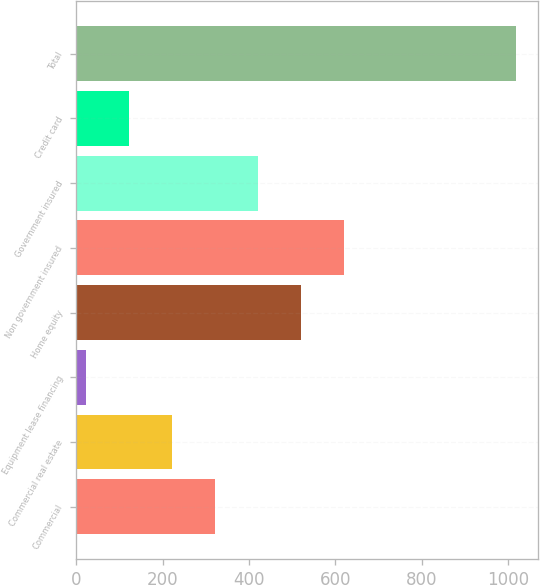<chart> <loc_0><loc_0><loc_500><loc_500><bar_chart><fcel>Commercial<fcel>Commercial real estate<fcel>Equipment lease financing<fcel>Home equity<fcel>Non government insured<fcel>Government insured<fcel>Credit card<fcel>Total<nl><fcel>320.8<fcel>221.2<fcel>22<fcel>520<fcel>619.6<fcel>420.4<fcel>121.6<fcel>1018<nl></chart> 